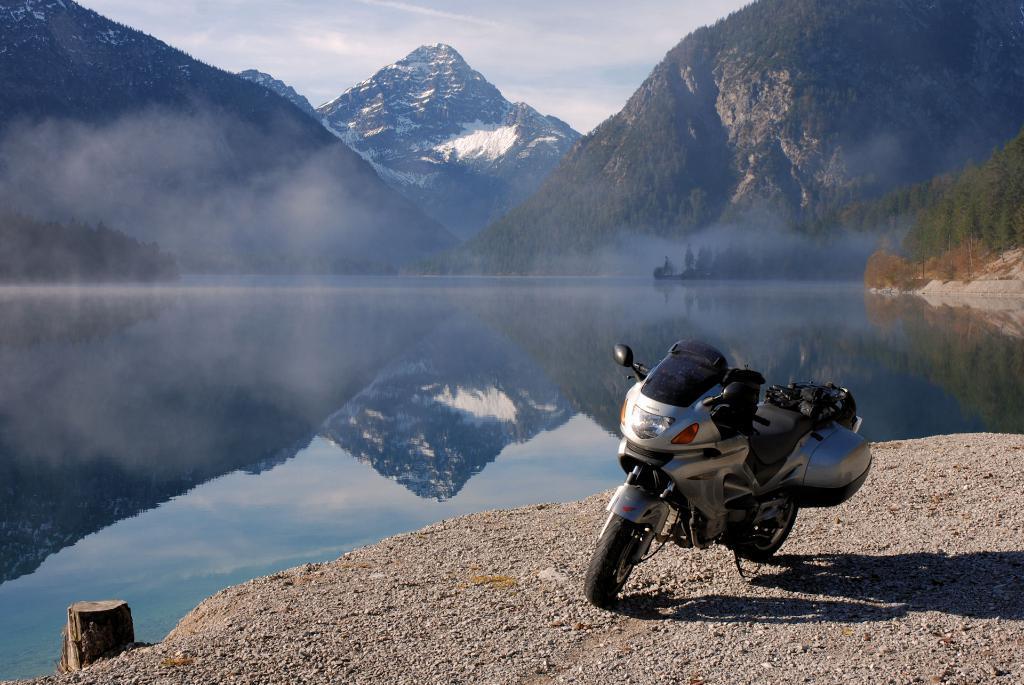Please provide a concise description of this image. In this image we can see a motorbike parked aside on the ground. We can also see some stones, a wooden log and a large water body. On the backside we can see a group of trees, the hills and the sky which looks cloudy. 